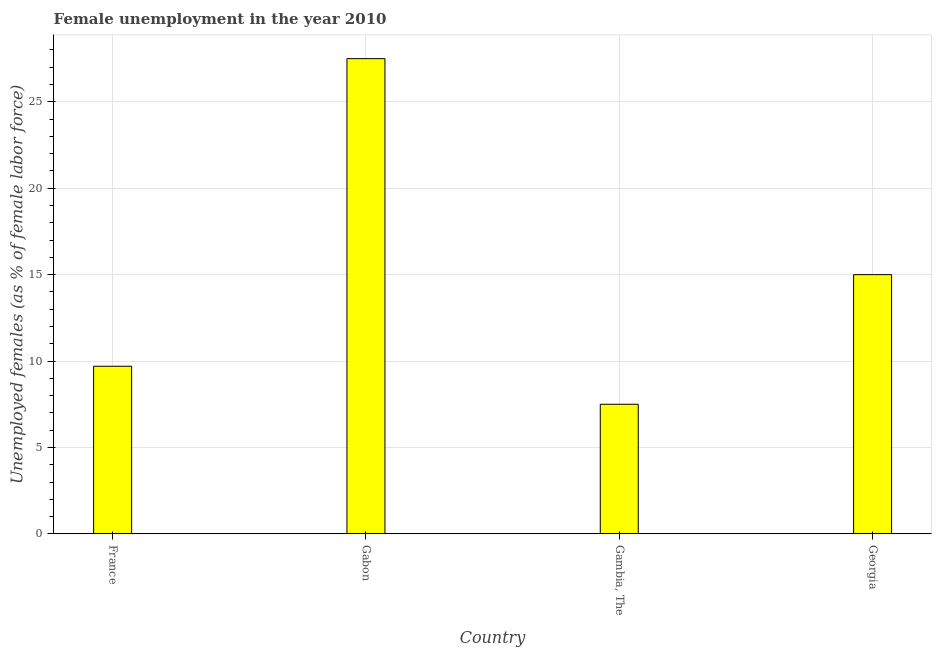Does the graph contain grids?
Your answer should be very brief. Yes. What is the title of the graph?
Give a very brief answer. Female unemployment in the year 2010. What is the label or title of the Y-axis?
Make the answer very short. Unemployed females (as % of female labor force). What is the unemployed females population in France?
Provide a short and direct response. 9.7. Across all countries, what is the minimum unemployed females population?
Keep it short and to the point. 7.5. In which country was the unemployed females population maximum?
Make the answer very short. Gabon. In which country was the unemployed females population minimum?
Your answer should be very brief. Gambia, The. What is the sum of the unemployed females population?
Ensure brevity in your answer.  59.7. What is the average unemployed females population per country?
Your answer should be very brief. 14.93. What is the median unemployed females population?
Provide a short and direct response. 12.35. What is the ratio of the unemployed females population in Gabon to that in Gambia, The?
Provide a succinct answer. 3.67. Is the unemployed females population in France less than that in Gabon?
Give a very brief answer. Yes. Is the difference between the unemployed females population in Gambia, The and Georgia greater than the difference between any two countries?
Your answer should be very brief. No. What is the difference between the highest and the second highest unemployed females population?
Make the answer very short. 12.5. Are all the bars in the graph horizontal?
Make the answer very short. No. What is the difference between two consecutive major ticks on the Y-axis?
Your answer should be compact. 5. Are the values on the major ticks of Y-axis written in scientific E-notation?
Give a very brief answer. No. What is the Unemployed females (as % of female labor force) of France?
Your response must be concise. 9.7. What is the Unemployed females (as % of female labor force) of Gabon?
Ensure brevity in your answer.  27.5. What is the Unemployed females (as % of female labor force) in Georgia?
Ensure brevity in your answer.  15. What is the difference between the Unemployed females (as % of female labor force) in France and Gabon?
Make the answer very short. -17.8. What is the difference between the Unemployed females (as % of female labor force) in France and Georgia?
Your answer should be compact. -5.3. What is the ratio of the Unemployed females (as % of female labor force) in France to that in Gabon?
Make the answer very short. 0.35. What is the ratio of the Unemployed females (as % of female labor force) in France to that in Gambia, The?
Your answer should be compact. 1.29. What is the ratio of the Unemployed females (as % of female labor force) in France to that in Georgia?
Provide a short and direct response. 0.65. What is the ratio of the Unemployed females (as % of female labor force) in Gabon to that in Gambia, The?
Give a very brief answer. 3.67. What is the ratio of the Unemployed females (as % of female labor force) in Gabon to that in Georgia?
Provide a short and direct response. 1.83. 